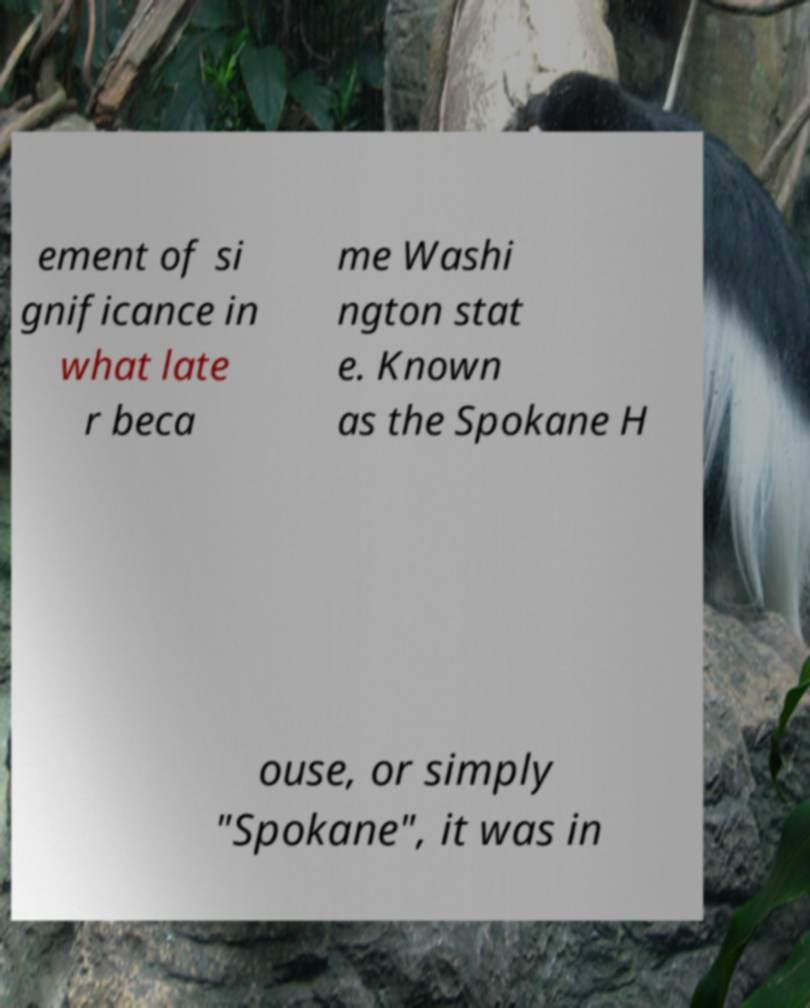Please identify and transcribe the text found in this image. ement of si gnificance in what late r beca me Washi ngton stat e. Known as the Spokane H ouse, or simply "Spokane", it was in 